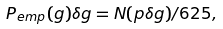<formula> <loc_0><loc_0><loc_500><loc_500>P _ { e m p } ( g ) \delta g = N ( p \delta g ) / 6 2 5 ,</formula> 